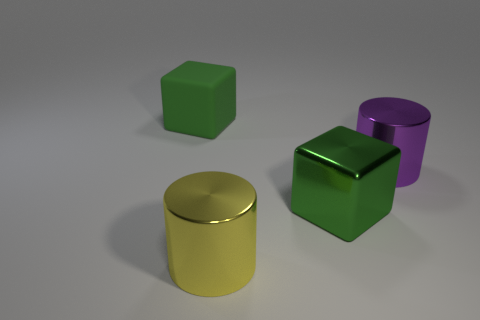Add 3 small cyan matte blocks. How many objects exist? 7 Subtract 0 blue cubes. How many objects are left? 4 Subtract all blue shiny balls. Subtract all green matte blocks. How many objects are left? 3 Add 4 yellow metallic objects. How many yellow metallic objects are left? 5 Add 1 yellow cylinders. How many yellow cylinders exist? 2 